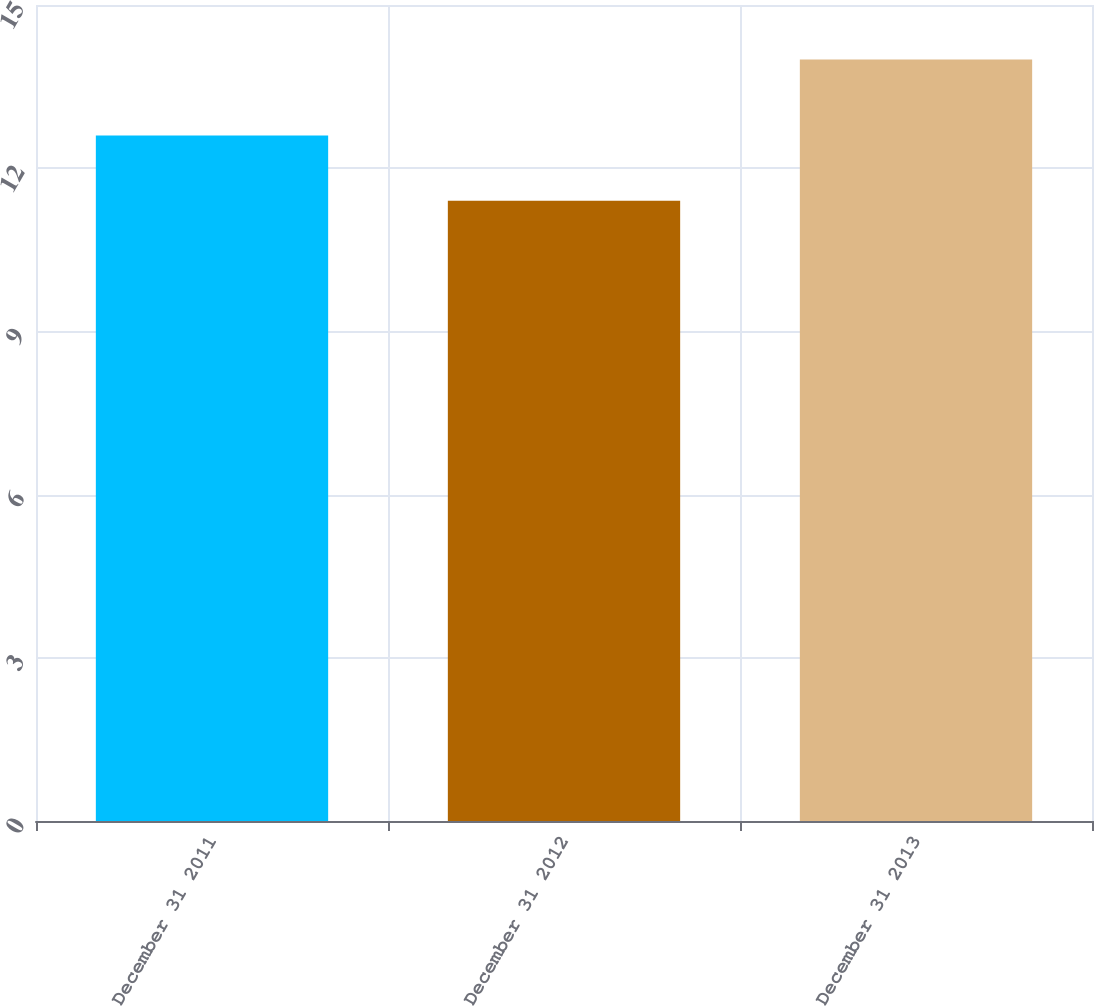Convert chart. <chart><loc_0><loc_0><loc_500><loc_500><bar_chart><fcel>December 31 2011<fcel>December 31 2012<fcel>December 31 2013<nl><fcel>12.6<fcel>11.4<fcel>14<nl></chart> 